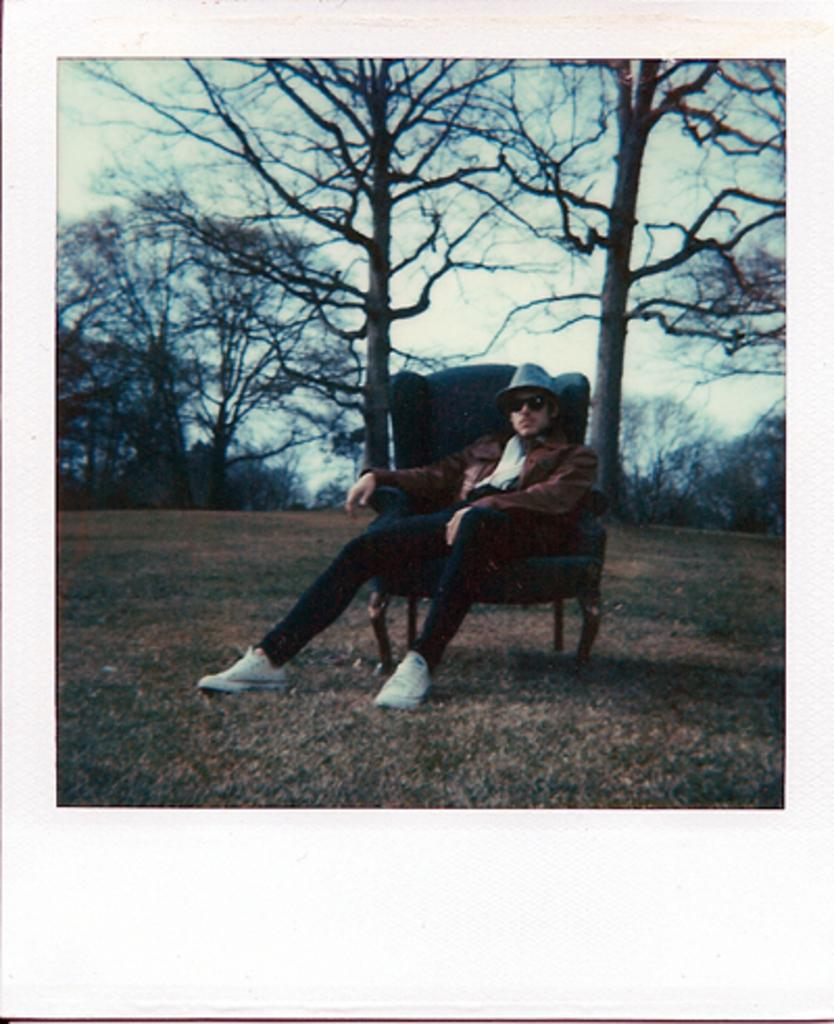Who is present in the image? There is a man in the image. What is the man wearing on his head? The man is wearing a cap. What is the man's position in the image? The man is sitting on a chair. What can be seen in the background of the image? There are trees in the background of the image. What is visible at the top of the image? The sky is visible at the top of the image. What type of argument is the man having with the goat in the image? There is no goat present in the image, so no such argument can be observed. 